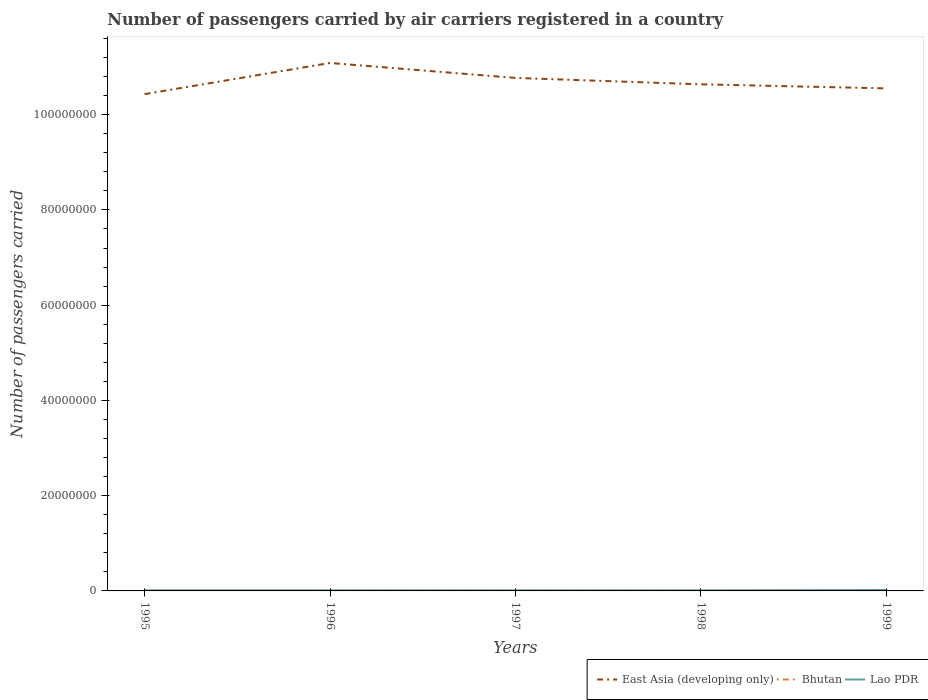Across all years, what is the maximum number of passengers carried by air carriers in East Asia (developing only)?
Provide a succinct answer. 1.04e+08. In which year was the number of passengers carried by air carriers in East Asia (developing only) maximum?
Your answer should be very brief. 1995. What is the total number of passengers carried by air carriers in Bhutan in the graph?
Give a very brief answer. 5400. What is the difference between the highest and the second highest number of passengers carried by air carriers in East Asia (developing only)?
Make the answer very short. 6.54e+06. How many lines are there?
Provide a short and direct response. 3. What is the difference between two consecutive major ticks on the Y-axis?
Provide a succinct answer. 2.00e+07. Are the values on the major ticks of Y-axis written in scientific E-notation?
Keep it short and to the point. No. Does the graph contain grids?
Make the answer very short. No. How many legend labels are there?
Your answer should be compact. 3. What is the title of the graph?
Your answer should be compact. Number of passengers carried by air carriers registered in a country. Does "Korea (Republic)" appear as one of the legend labels in the graph?
Ensure brevity in your answer.  No. What is the label or title of the Y-axis?
Keep it short and to the point. Number of passengers carried. What is the Number of passengers carried of East Asia (developing only) in 1995?
Provide a succinct answer. 1.04e+08. What is the Number of passengers carried of Bhutan in 1995?
Offer a very short reply. 2.97e+04. What is the Number of passengers carried in Lao PDR in 1995?
Your answer should be compact. 1.24e+05. What is the Number of passengers carried in East Asia (developing only) in 1996?
Provide a short and direct response. 1.11e+08. What is the Number of passengers carried of Bhutan in 1996?
Your answer should be very brief. 3.50e+04. What is the Number of passengers carried of Lao PDR in 1996?
Offer a very short reply. 1.24e+05. What is the Number of passengers carried of East Asia (developing only) in 1997?
Your answer should be compact. 1.08e+08. What is the Number of passengers carried of Bhutan in 1997?
Give a very brief answer. 3.61e+04. What is the Number of passengers carried of Lao PDR in 1997?
Your response must be concise. 1.24e+05. What is the Number of passengers carried of East Asia (developing only) in 1998?
Give a very brief answer. 1.06e+08. What is the Number of passengers carried of Bhutan in 1998?
Provide a succinct answer. 3.61e+04. What is the Number of passengers carried of Lao PDR in 1998?
Offer a terse response. 1.24e+05. What is the Number of passengers carried in East Asia (developing only) in 1999?
Provide a succinct answer. 1.06e+08. What is the Number of passengers carried of Bhutan in 1999?
Your answer should be very brief. 3.07e+04. What is the Number of passengers carried in Lao PDR in 1999?
Offer a very short reply. 1.97e+05. Across all years, what is the maximum Number of passengers carried in East Asia (developing only)?
Your response must be concise. 1.11e+08. Across all years, what is the maximum Number of passengers carried in Bhutan?
Your response must be concise. 3.61e+04. Across all years, what is the maximum Number of passengers carried of Lao PDR?
Make the answer very short. 1.97e+05. Across all years, what is the minimum Number of passengers carried of East Asia (developing only)?
Your answer should be very brief. 1.04e+08. Across all years, what is the minimum Number of passengers carried in Bhutan?
Provide a succinct answer. 2.97e+04. Across all years, what is the minimum Number of passengers carried of Lao PDR?
Provide a succinct answer. 1.24e+05. What is the total Number of passengers carried in East Asia (developing only) in the graph?
Offer a very short reply. 5.35e+08. What is the total Number of passengers carried in Bhutan in the graph?
Provide a short and direct response. 1.68e+05. What is the total Number of passengers carried in Lao PDR in the graph?
Provide a succinct answer. 6.95e+05. What is the difference between the Number of passengers carried of East Asia (developing only) in 1995 and that in 1996?
Offer a terse response. -6.54e+06. What is the difference between the Number of passengers carried in Bhutan in 1995 and that in 1996?
Make the answer very short. -5300. What is the difference between the Number of passengers carried in East Asia (developing only) in 1995 and that in 1997?
Offer a terse response. -3.40e+06. What is the difference between the Number of passengers carried of Bhutan in 1995 and that in 1997?
Offer a terse response. -6400. What is the difference between the Number of passengers carried in East Asia (developing only) in 1995 and that in 1998?
Provide a succinct answer. -2.06e+06. What is the difference between the Number of passengers carried in Bhutan in 1995 and that in 1998?
Give a very brief answer. -6400. What is the difference between the Number of passengers carried in Lao PDR in 1995 and that in 1998?
Your answer should be very brief. 400. What is the difference between the Number of passengers carried of East Asia (developing only) in 1995 and that in 1999?
Offer a terse response. -1.20e+06. What is the difference between the Number of passengers carried in Bhutan in 1995 and that in 1999?
Your answer should be compact. -1000. What is the difference between the Number of passengers carried of Lao PDR in 1995 and that in 1999?
Offer a terse response. -7.27e+04. What is the difference between the Number of passengers carried in East Asia (developing only) in 1996 and that in 1997?
Ensure brevity in your answer.  3.14e+06. What is the difference between the Number of passengers carried of Bhutan in 1996 and that in 1997?
Provide a succinct answer. -1100. What is the difference between the Number of passengers carried of East Asia (developing only) in 1996 and that in 1998?
Your response must be concise. 4.48e+06. What is the difference between the Number of passengers carried in Bhutan in 1996 and that in 1998?
Offer a very short reply. -1100. What is the difference between the Number of passengers carried in Lao PDR in 1996 and that in 1998?
Provide a short and direct response. 400. What is the difference between the Number of passengers carried in East Asia (developing only) in 1996 and that in 1999?
Provide a short and direct response. 5.34e+06. What is the difference between the Number of passengers carried in Bhutan in 1996 and that in 1999?
Your response must be concise. 4300. What is the difference between the Number of passengers carried in Lao PDR in 1996 and that in 1999?
Make the answer very short. -7.27e+04. What is the difference between the Number of passengers carried in East Asia (developing only) in 1997 and that in 1998?
Your answer should be very brief. 1.34e+06. What is the difference between the Number of passengers carried in Bhutan in 1997 and that in 1998?
Your answer should be very brief. 0. What is the difference between the Number of passengers carried in East Asia (developing only) in 1997 and that in 1999?
Give a very brief answer. 2.20e+06. What is the difference between the Number of passengers carried in Bhutan in 1997 and that in 1999?
Offer a very short reply. 5400. What is the difference between the Number of passengers carried in Lao PDR in 1997 and that in 1999?
Ensure brevity in your answer.  -7.27e+04. What is the difference between the Number of passengers carried in East Asia (developing only) in 1998 and that in 1999?
Your answer should be very brief. 8.56e+05. What is the difference between the Number of passengers carried in Bhutan in 1998 and that in 1999?
Your response must be concise. 5400. What is the difference between the Number of passengers carried of Lao PDR in 1998 and that in 1999?
Provide a short and direct response. -7.31e+04. What is the difference between the Number of passengers carried of East Asia (developing only) in 1995 and the Number of passengers carried of Bhutan in 1996?
Provide a succinct answer. 1.04e+08. What is the difference between the Number of passengers carried of East Asia (developing only) in 1995 and the Number of passengers carried of Lao PDR in 1996?
Provide a short and direct response. 1.04e+08. What is the difference between the Number of passengers carried in Bhutan in 1995 and the Number of passengers carried in Lao PDR in 1996?
Ensure brevity in your answer.  -9.48e+04. What is the difference between the Number of passengers carried in East Asia (developing only) in 1995 and the Number of passengers carried in Bhutan in 1997?
Offer a terse response. 1.04e+08. What is the difference between the Number of passengers carried of East Asia (developing only) in 1995 and the Number of passengers carried of Lao PDR in 1997?
Your response must be concise. 1.04e+08. What is the difference between the Number of passengers carried of Bhutan in 1995 and the Number of passengers carried of Lao PDR in 1997?
Make the answer very short. -9.48e+04. What is the difference between the Number of passengers carried in East Asia (developing only) in 1995 and the Number of passengers carried in Bhutan in 1998?
Your response must be concise. 1.04e+08. What is the difference between the Number of passengers carried of East Asia (developing only) in 1995 and the Number of passengers carried of Lao PDR in 1998?
Offer a terse response. 1.04e+08. What is the difference between the Number of passengers carried in Bhutan in 1995 and the Number of passengers carried in Lao PDR in 1998?
Your answer should be very brief. -9.44e+04. What is the difference between the Number of passengers carried of East Asia (developing only) in 1995 and the Number of passengers carried of Bhutan in 1999?
Give a very brief answer. 1.04e+08. What is the difference between the Number of passengers carried of East Asia (developing only) in 1995 and the Number of passengers carried of Lao PDR in 1999?
Provide a short and direct response. 1.04e+08. What is the difference between the Number of passengers carried in Bhutan in 1995 and the Number of passengers carried in Lao PDR in 1999?
Offer a terse response. -1.68e+05. What is the difference between the Number of passengers carried of East Asia (developing only) in 1996 and the Number of passengers carried of Bhutan in 1997?
Your response must be concise. 1.11e+08. What is the difference between the Number of passengers carried of East Asia (developing only) in 1996 and the Number of passengers carried of Lao PDR in 1997?
Keep it short and to the point. 1.11e+08. What is the difference between the Number of passengers carried in Bhutan in 1996 and the Number of passengers carried in Lao PDR in 1997?
Your answer should be compact. -8.95e+04. What is the difference between the Number of passengers carried of East Asia (developing only) in 1996 and the Number of passengers carried of Bhutan in 1998?
Ensure brevity in your answer.  1.11e+08. What is the difference between the Number of passengers carried of East Asia (developing only) in 1996 and the Number of passengers carried of Lao PDR in 1998?
Give a very brief answer. 1.11e+08. What is the difference between the Number of passengers carried in Bhutan in 1996 and the Number of passengers carried in Lao PDR in 1998?
Offer a very short reply. -8.91e+04. What is the difference between the Number of passengers carried in East Asia (developing only) in 1996 and the Number of passengers carried in Bhutan in 1999?
Ensure brevity in your answer.  1.11e+08. What is the difference between the Number of passengers carried of East Asia (developing only) in 1996 and the Number of passengers carried of Lao PDR in 1999?
Keep it short and to the point. 1.11e+08. What is the difference between the Number of passengers carried of Bhutan in 1996 and the Number of passengers carried of Lao PDR in 1999?
Keep it short and to the point. -1.62e+05. What is the difference between the Number of passengers carried in East Asia (developing only) in 1997 and the Number of passengers carried in Bhutan in 1998?
Give a very brief answer. 1.08e+08. What is the difference between the Number of passengers carried in East Asia (developing only) in 1997 and the Number of passengers carried in Lao PDR in 1998?
Make the answer very short. 1.08e+08. What is the difference between the Number of passengers carried of Bhutan in 1997 and the Number of passengers carried of Lao PDR in 1998?
Provide a short and direct response. -8.80e+04. What is the difference between the Number of passengers carried in East Asia (developing only) in 1997 and the Number of passengers carried in Bhutan in 1999?
Your response must be concise. 1.08e+08. What is the difference between the Number of passengers carried of East Asia (developing only) in 1997 and the Number of passengers carried of Lao PDR in 1999?
Ensure brevity in your answer.  1.08e+08. What is the difference between the Number of passengers carried in Bhutan in 1997 and the Number of passengers carried in Lao PDR in 1999?
Ensure brevity in your answer.  -1.61e+05. What is the difference between the Number of passengers carried of East Asia (developing only) in 1998 and the Number of passengers carried of Bhutan in 1999?
Offer a very short reply. 1.06e+08. What is the difference between the Number of passengers carried in East Asia (developing only) in 1998 and the Number of passengers carried in Lao PDR in 1999?
Your answer should be compact. 1.06e+08. What is the difference between the Number of passengers carried in Bhutan in 1998 and the Number of passengers carried in Lao PDR in 1999?
Your answer should be compact. -1.61e+05. What is the average Number of passengers carried in East Asia (developing only) per year?
Offer a very short reply. 1.07e+08. What is the average Number of passengers carried of Bhutan per year?
Ensure brevity in your answer.  3.35e+04. What is the average Number of passengers carried of Lao PDR per year?
Your answer should be compact. 1.39e+05. In the year 1995, what is the difference between the Number of passengers carried of East Asia (developing only) and Number of passengers carried of Bhutan?
Your response must be concise. 1.04e+08. In the year 1995, what is the difference between the Number of passengers carried in East Asia (developing only) and Number of passengers carried in Lao PDR?
Keep it short and to the point. 1.04e+08. In the year 1995, what is the difference between the Number of passengers carried in Bhutan and Number of passengers carried in Lao PDR?
Give a very brief answer. -9.48e+04. In the year 1996, what is the difference between the Number of passengers carried in East Asia (developing only) and Number of passengers carried in Bhutan?
Keep it short and to the point. 1.11e+08. In the year 1996, what is the difference between the Number of passengers carried of East Asia (developing only) and Number of passengers carried of Lao PDR?
Provide a short and direct response. 1.11e+08. In the year 1996, what is the difference between the Number of passengers carried in Bhutan and Number of passengers carried in Lao PDR?
Ensure brevity in your answer.  -8.95e+04. In the year 1997, what is the difference between the Number of passengers carried in East Asia (developing only) and Number of passengers carried in Bhutan?
Your answer should be very brief. 1.08e+08. In the year 1997, what is the difference between the Number of passengers carried in East Asia (developing only) and Number of passengers carried in Lao PDR?
Provide a short and direct response. 1.08e+08. In the year 1997, what is the difference between the Number of passengers carried of Bhutan and Number of passengers carried of Lao PDR?
Your answer should be compact. -8.84e+04. In the year 1998, what is the difference between the Number of passengers carried of East Asia (developing only) and Number of passengers carried of Bhutan?
Provide a succinct answer. 1.06e+08. In the year 1998, what is the difference between the Number of passengers carried in East Asia (developing only) and Number of passengers carried in Lao PDR?
Provide a short and direct response. 1.06e+08. In the year 1998, what is the difference between the Number of passengers carried in Bhutan and Number of passengers carried in Lao PDR?
Give a very brief answer. -8.80e+04. In the year 1999, what is the difference between the Number of passengers carried of East Asia (developing only) and Number of passengers carried of Bhutan?
Your response must be concise. 1.05e+08. In the year 1999, what is the difference between the Number of passengers carried of East Asia (developing only) and Number of passengers carried of Lao PDR?
Your answer should be compact. 1.05e+08. In the year 1999, what is the difference between the Number of passengers carried of Bhutan and Number of passengers carried of Lao PDR?
Provide a succinct answer. -1.66e+05. What is the ratio of the Number of passengers carried of East Asia (developing only) in 1995 to that in 1996?
Offer a terse response. 0.94. What is the ratio of the Number of passengers carried in Bhutan in 1995 to that in 1996?
Offer a very short reply. 0.85. What is the ratio of the Number of passengers carried of Lao PDR in 1995 to that in 1996?
Provide a short and direct response. 1. What is the ratio of the Number of passengers carried of East Asia (developing only) in 1995 to that in 1997?
Ensure brevity in your answer.  0.97. What is the ratio of the Number of passengers carried in Bhutan in 1995 to that in 1997?
Keep it short and to the point. 0.82. What is the ratio of the Number of passengers carried in Lao PDR in 1995 to that in 1997?
Offer a terse response. 1. What is the ratio of the Number of passengers carried of East Asia (developing only) in 1995 to that in 1998?
Keep it short and to the point. 0.98. What is the ratio of the Number of passengers carried in Bhutan in 1995 to that in 1998?
Provide a succinct answer. 0.82. What is the ratio of the Number of passengers carried of Lao PDR in 1995 to that in 1998?
Give a very brief answer. 1. What is the ratio of the Number of passengers carried of East Asia (developing only) in 1995 to that in 1999?
Provide a succinct answer. 0.99. What is the ratio of the Number of passengers carried of Bhutan in 1995 to that in 1999?
Provide a short and direct response. 0.97. What is the ratio of the Number of passengers carried in Lao PDR in 1995 to that in 1999?
Provide a short and direct response. 0.63. What is the ratio of the Number of passengers carried in East Asia (developing only) in 1996 to that in 1997?
Your answer should be very brief. 1.03. What is the ratio of the Number of passengers carried in Bhutan in 1996 to that in 1997?
Make the answer very short. 0.97. What is the ratio of the Number of passengers carried of East Asia (developing only) in 1996 to that in 1998?
Ensure brevity in your answer.  1.04. What is the ratio of the Number of passengers carried of Bhutan in 1996 to that in 1998?
Give a very brief answer. 0.97. What is the ratio of the Number of passengers carried of East Asia (developing only) in 1996 to that in 1999?
Offer a terse response. 1.05. What is the ratio of the Number of passengers carried in Bhutan in 1996 to that in 1999?
Provide a succinct answer. 1.14. What is the ratio of the Number of passengers carried in Lao PDR in 1996 to that in 1999?
Give a very brief answer. 0.63. What is the ratio of the Number of passengers carried of East Asia (developing only) in 1997 to that in 1998?
Your answer should be very brief. 1.01. What is the ratio of the Number of passengers carried of Bhutan in 1997 to that in 1998?
Offer a terse response. 1. What is the ratio of the Number of passengers carried of East Asia (developing only) in 1997 to that in 1999?
Provide a short and direct response. 1.02. What is the ratio of the Number of passengers carried in Bhutan in 1997 to that in 1999?
Keep it short and to the point. 1.18. What is the ratio of the Number of passengers carried in Lao PDR in 1997 to that in 1999?
Your answer should be very brief. 0.63. What is the ratio of the Number of passengers carried in East Asia (developing only) in 1998 to that in 1999?
Your answer should be compact. 1.01. What is the ratio of the Number of passengers carried in Bhutan in 1998 to that in 1999?
Give a very brief answer. 1.18. What is the ratio of the Number of passengers carried of Lao PDR in 1998 to that in 1999?
Your answer should be very brief. 0.63. What is the difference between the highest and the second highest Number of passengers carried of East Asia (developing only)?
Keep it short and to the point. 3.14e+06. What is the difference between the highest and the second highest Number of passengers carried in Bhutan?
Offer a very short reply. 0. What is the difference between the highest and the second highest Number of passengers carried in Lao PDR?
Offer a very short reply. 7.27e+04. What is the difference between the highest and the lowest Number of passengers carried in East Asia (developing only)?
Ensure brevity in your answer.  6.54e+06. What is the difference between the highest and the lowest Number of passengers carried in Bhutan?
Make the answer very short. 6400. What is the difference between the highest and the lowest Number of passengers carried in Lao PDR?
Offer a terse response. 7.31e+04. 